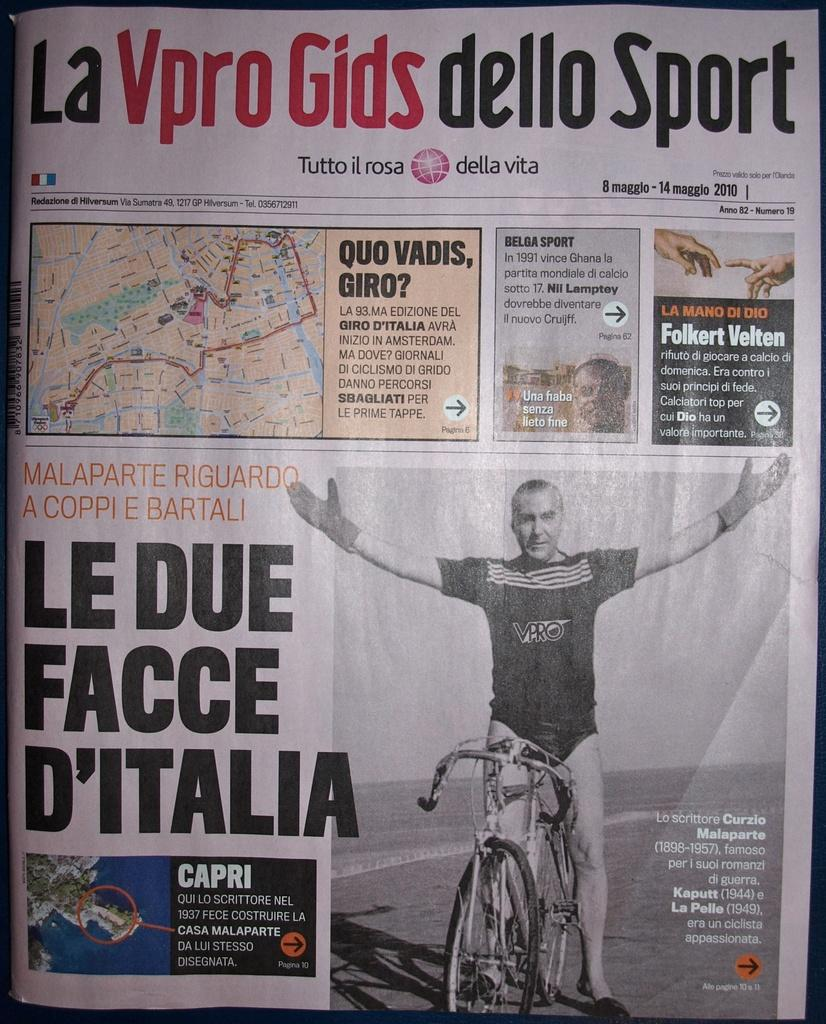What is the main subject of the image? The main subject of the image is the front page of a newspaper. What can be seen on the front page of the newspaper? The front page contains pictures and text. How does the newspaper help people remember their memories in the image? The image does not show the newspaper helping people remember their memories, as it only displays the front page with pictures and text. 